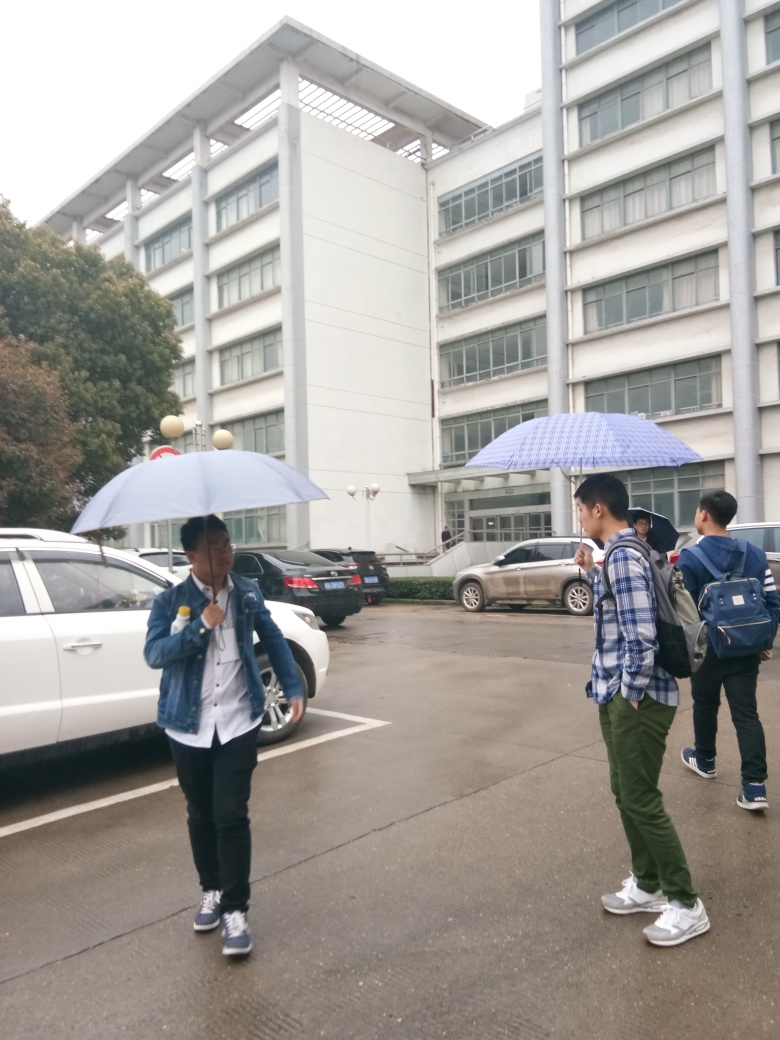What is the weather like in this image? The weather appears to be overcast, as evidenced by the grey sky and the fact that two individuals are carrying umbrellas, suggesting it is likely raining or there is a chance of rain. 